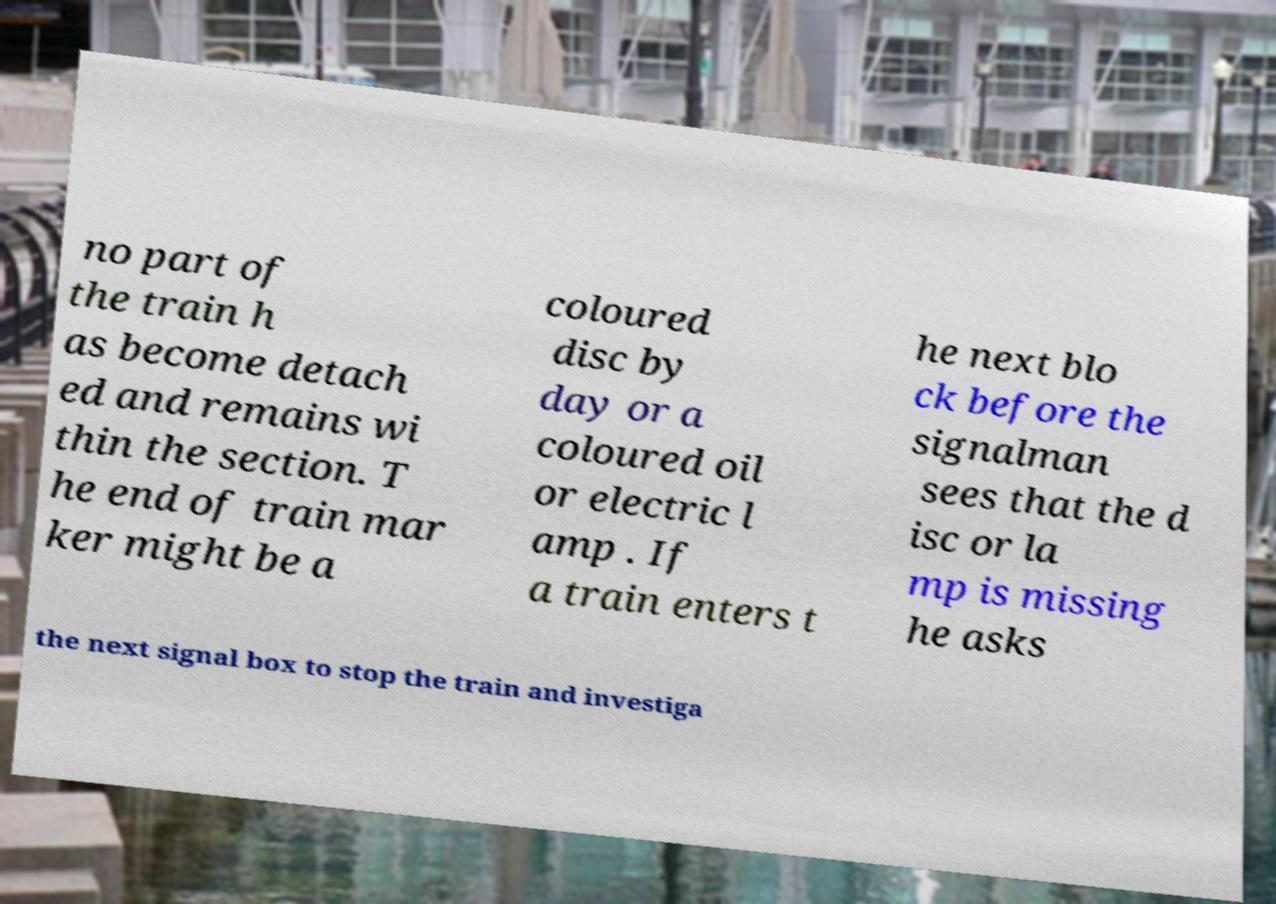I need the written content from this picture converted into text. Can you do that? no part of the train h as become detach ed and remains wi thin the section. T he end of train mar ker might be a coloured disc by day or a coloured oil or electric l amp . If a train enters t he next blo ck before the signalman sees that the d isc or la mp is missing he asks the next signal box to stop the train and investiga 